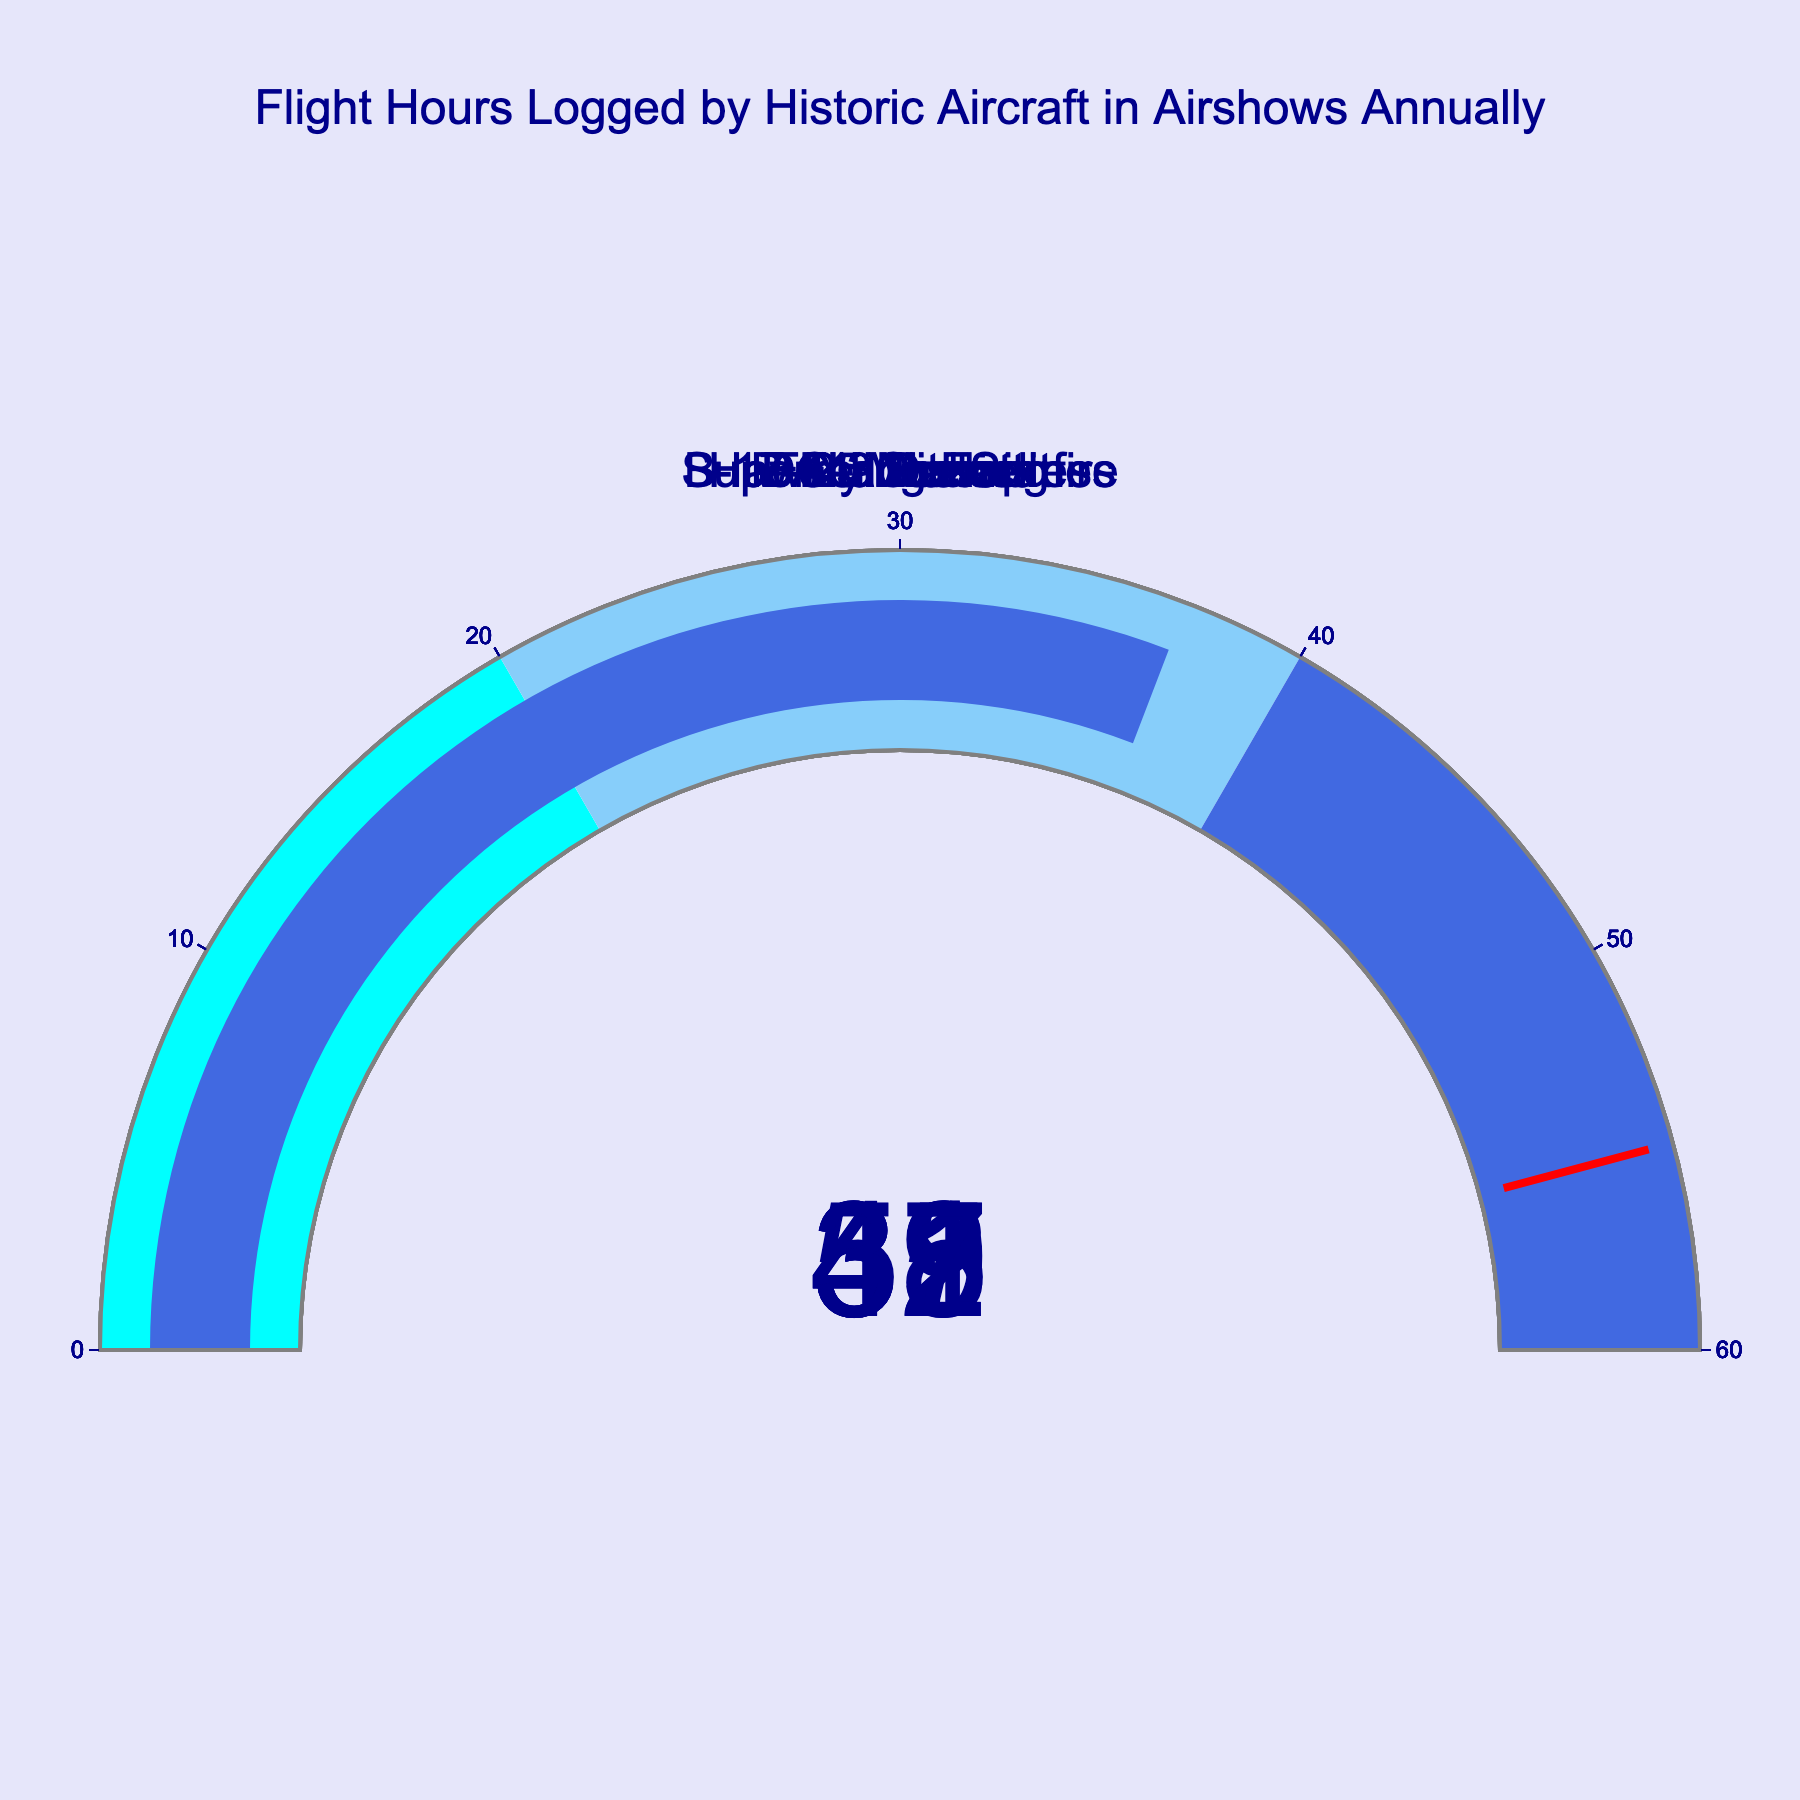What is the title of the figure? The title of the figure is located at the top and typically provides a description of what the chart represents.
Answer: Flight Hours Logged by Historic Aircraft in Airshows Annually How many gauges are displayed in the figure? By counting the number of gauge charts shown in the figure, we can determine how many different historic aircraft are represented.
Answer: Seven Which aircraft logged the most flight hours in airshows annually? By comparing the values shown on each gauge, we can identify the aircraft with the highest number of flight hours. The DC-3 Dakota has the highest value.
Answer: DC-3 Dakota How many flight hours were logged by the Supermarine Spitfire annually? Find the gauge titled "Supermarine Spitfire" and read the value displayed on it.
Answer: 42 What is the sum of the flight hours logged by the P-51 Mustang and the Hawker Hurricane? Add the flight hours of the P-51 Mustang and the Hawker Hurricane. The P-51 Mustang has 48 hours and the Hawker Hurricane has 31 hours. Sum is 48 + 31.
Answer: 79 Which aircraft logged fewer flight hours, the B-25 Mitchell or the F4U Corsair? Compare the flight hours on the gauges for the B-25 Mitchell and the F4U Corsair. The B-25 Mitchell has 37 hours, and the F4U Corsair has 39 hours.
Answer: B-25 Mitchell Are there any aircraft that logged flight hours in the 40-60 range? If so, which ones? Look for gauges where the value falls between 40 and 60. The aircraft that fall into this range are the P-51 Mustang, Supermarine Spitfire, and DC-3 Dakota.
Answer: Yes, P-51 Mustang, Supermarine Spitfire, DC-3 Dakota What is the average flight hours logged by the B-17 Flying Fortress, F4U Corsair, and B-25 Mitchell? Add the flight hours of the B-17 Flying Fortress (35), F4U Corsair (39), and B-25 Mitchell (37) and then divide by 3. The sum is 35 + 39 + 37 = 111. Average is 111 / 3.
Answer: 37 Which aircraft logged more flight hours, the B-17 Flying Fortress or the Hawker Hurricane? Compare the flight hours on the gauges for the B-17 Flying Fortress and Hawker Hurricane. The B-17 Flying Fortress has 35 hours, and the Hawker Hurricane has 31 hours.
Answer: B-17 Flying Fortress How many aircraft logged less than 50 flight hours? Count the gauges where the value is less than 50. B-17 Flying Fortress, Supermarine Spitfire, F4U Corsair, Hawker Hurricane, and B-25 Mitchell all logged less than 50 hours.
Answer: Five 